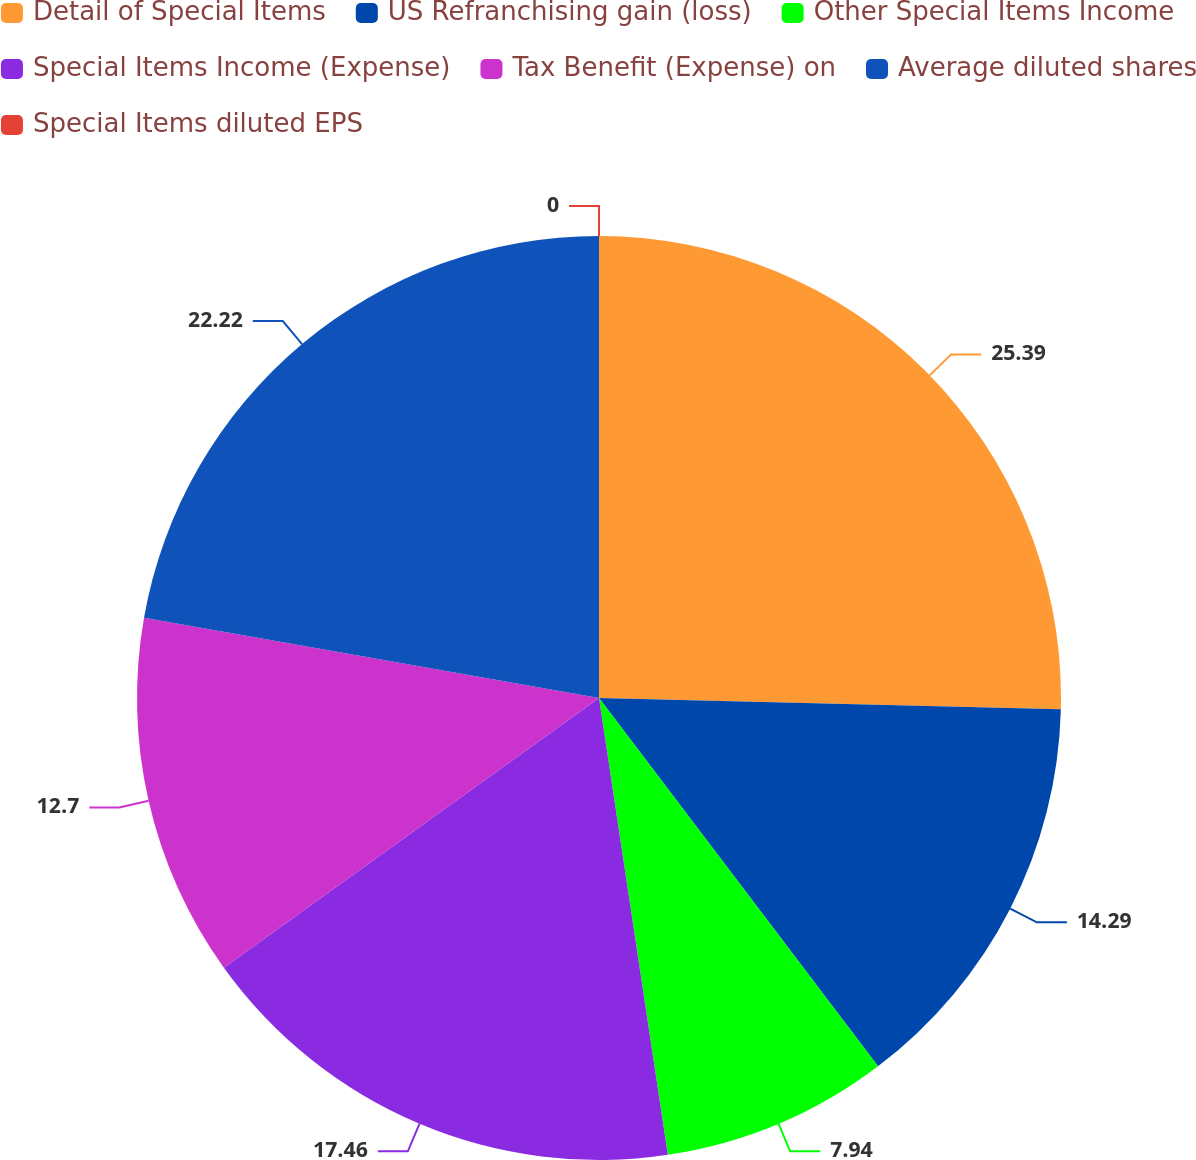Convert chart to OTSL. <chart><loc_0><loc_0><loc_500><loc_500><pie_chart><fcel>Detail of Special Items<fcel>US Refranchising gain (loss)<fcel>Other Special Items Income<fcel>Special Items Income (Expense)<fcel>Tax Benefit (Expense) on<fcel>Average diluted shares<fcel>Special Items diluted EPS<nl><fcel>25.39%<fcel>14.29%<fcel>7.94%<fcel>17.46%<fcel>12.7%<fcel>22.22%<fcel>0.0%<nl></chart> 